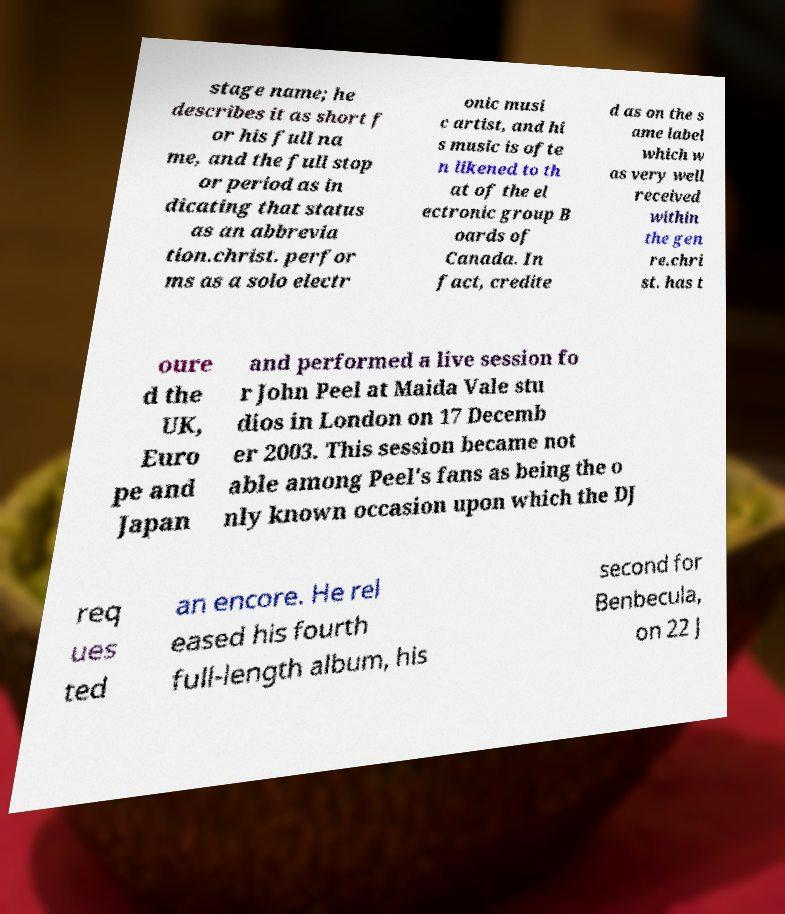Can you read and provide the text displayed in the image?This photo seems to have some interesting text. Can you extract and type it out for me? stage name; he describes it as short f or his full na me, and the full stop or period as in dicating that status as an abbrevia tion.christ. perfor ms as a solo electr onic musi c artist, and hi s music is ofte n likened to th at of the el ectronic group B oards of Canada. In fact, credite d as on the s ame label which w as very well received within the gen re.chri st. has t oure d the UK, Euro pe and Japan and performed a live session fo r John Peel at Maida Vale stu dios in London on 17 Decemb er 2003. This session became not able among Peel's fans as being the o nly known occasion upon which the DJ req ues ted an encore. He rel eased his fourth full-length album, his second for Benbecula, on 22 J 